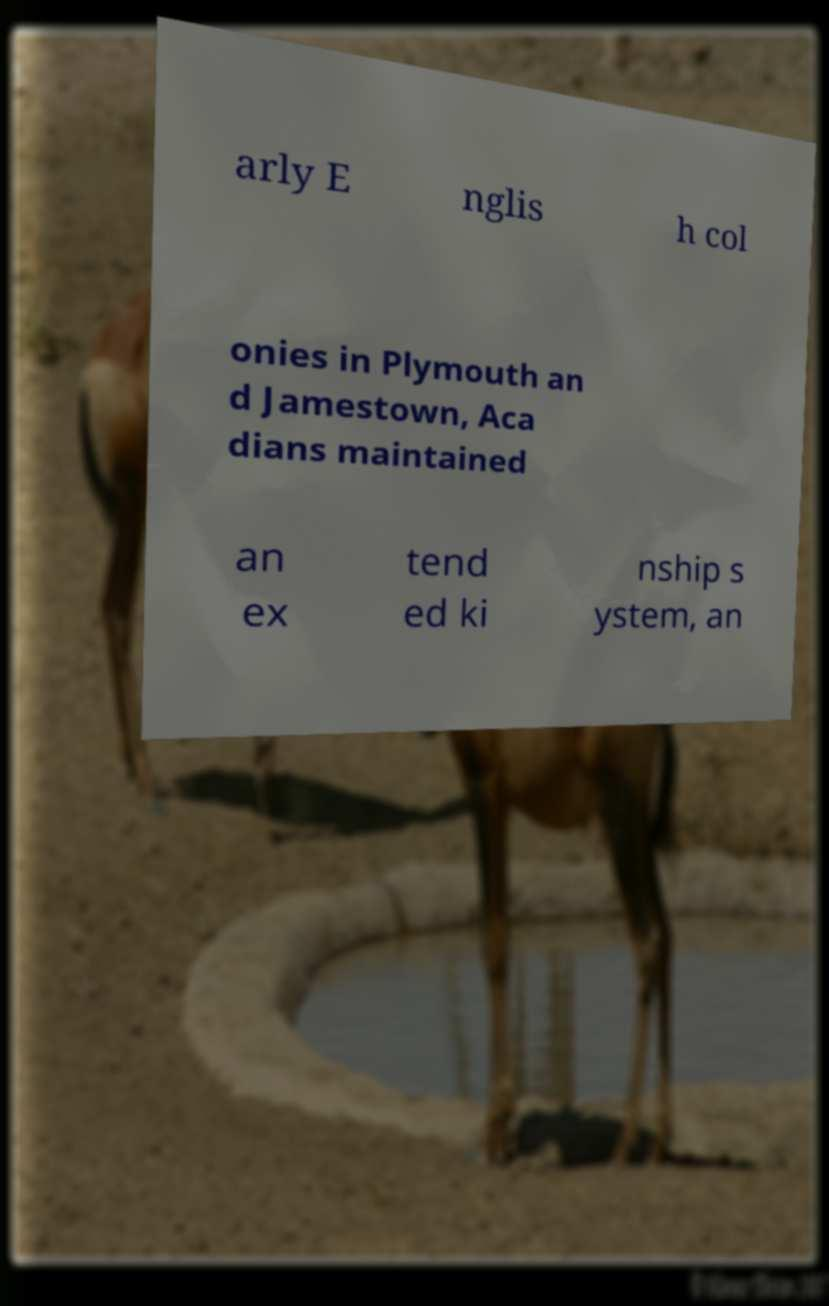For documentation purposes, I need the text within this image transcribed. Could you provide that? arly E nglis h col onies in Plymouth an d Jamestown, Aca dians maintained an ex tend ed ki nship s ystem, an 